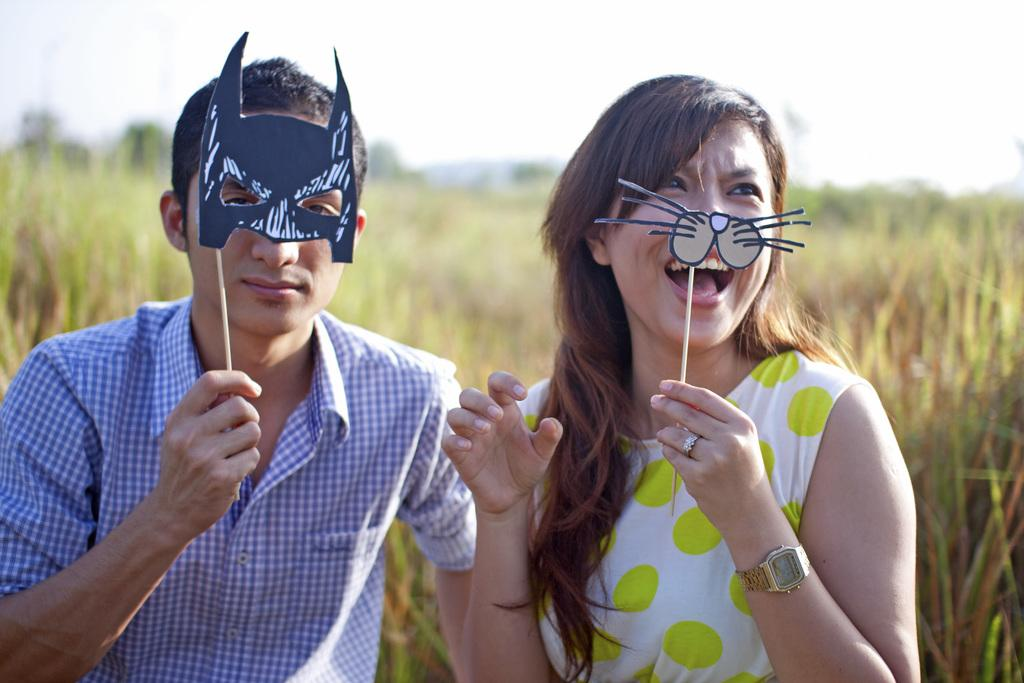How many people are present in the image? There are two people in the image, a man and a woman. What are the man and woman holding in the image? Both the man and woman are holding masks. What expressions do the man and woman have in the image? The man and woman are smiling in the image. What can be seen in the background of the image? There are plants and the sky visible in the background of the image. How would you describe the background of the image? The background is blurry in the image. What type of root can be seen growing from the man's knee in the image? There is no root growing from the man's knee in the image, as the image only features a man and a woman holding masks and smiling. 